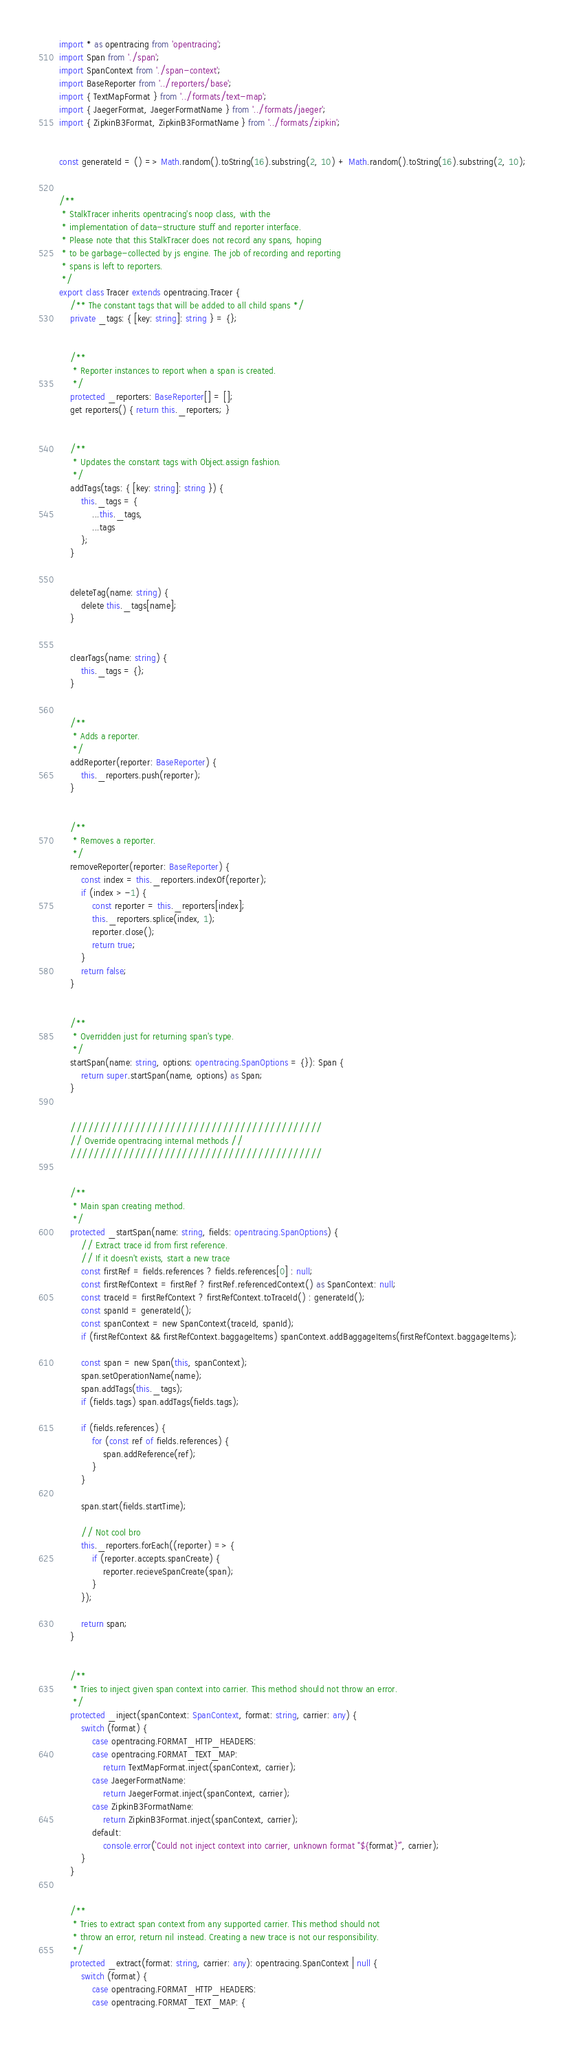Convert code to text. <code><loc_0><loc_0><loc_500><loc_500><_TypeScript_>import * as opentracing from 'opentracing';
import Span from './span';
import SpanContext from './span-context';
import BaseReporter from '../reporters/base';
import { TextMapFormat } from '../formats/text-map';
import { JaegerFormat, JaegerFormatName } from '../formats/jaeger';
import { ZipkinB3Format, ZipkinB3FormatName } from '../formats/zipkin';


const generateId = () => Math.random().toString(16).substring(2, 10) + Math.random().toString(16).substring(2, 10);


/**
 * StalkTracer inherits opentracing's noop class, with the
 * implementation of data-structure stuff and reporter interface.
 * Please note that this StalkTracer does not record any spans, hoping
 * to be garbage-collected by js engine. The job of recording and reporting
 * spans is left to reporters.
 */
export class Tracer extends opentracing.Tracer {
    /** The constant tags that will be added to all child spans */
    private _tags: { [key: string]: string } = {};


    /**
     * Reporter instances to report when a span is created.
     */
    protected _reporters: BaseReporter[] = [];
    get reporters() { return this._reporters; }


    /**
     * Updates the constant tags with Object.assign fashion.
     */
    addTags(tags: { [key: string]: string }) {
        this._tags = {
            ...this._tags,
            ...tags
        };
    }


    deleteTag(name: string) {
        delete this._tags[name];
    }


    clearTags(name: string) {
        this._tags = {};
    }


    /**
     * Adds a reporter.
     */
    addReporter(reporter: BaseReporter) {
        this._reporters.push(reporter);
    }


    /**
     * Removes a reporter.
     */
    removeReporter(reporter: BaseReporter) {
        const index = this._reporters.indexOf(reporter);
        if (index > -1) {
            const reporter = this._reporters[index];
            this._reporters.splice(index, 1);
            reporter.close();
            return true;
        }
        return false;
    }


    /**
     * Overridden just for returning span's type.
     */
    startSpan(name: string, options: opentracing.SpanOptions = {}): Span {
        return super.startSpan(name, options) as Span;
    }


    ///////////////////////////////////////////
    // Override opentracing internal methods //
    ///////////////////////////////////////////


    /**
     * Main span creating method.
     */
    protected _startSpan(name: string, fields: opentracing.SpanOptions) {
        // Extract trace id from first reference.
        // If it doesn't exists, start a new trace
        const firstRef = fields.references ? fields.references[0] : null;
        const firstRefContext = firstRef ? firstRef.referencedContext() as SpanContext: null;
        const traceId = firstRefContext ? firstRefContext.toTraceId() : generateId();
        const spanId = generateId();
        const spanContext = new SpanContext(traceId, spanId);
        if (firstRefContext && firstRefContext.baggageItems) spanContext.addBaggageItems(firstRefContext.baggageItems);

        const span = new Span(this, spanContext);
        span.setOperationName(name);
        span.addTags(this._tags);
        if (fields.tags) span.addTags(fields.tags);

        if (fields.references) {
            for (const ref of fields.references) {
                span.addReference(ref);
            }
        }

        span.start(fields.startTime);

        // Not cool bro
        this._reporters.forEach((reporter) => {
            if (reporter.accepts.spanCreate) {
                reporter.recieveSpanCreate(span);
            }
        });

        return span;
    }


    /**
     * Tries to inject given span context into carrier. This method should not throw an error.
     */
    protected _inject(spanContext: SpanContext, format: string, carrier: any) {
        switch (format) {
            case opentracing.FORMAT_HTTP_HEADERS:
            case opentracing.FORMAT_TEXT_MAP:
                return TextMapFormat.inject(spanContext, carrier);
            case JaegerFormatName:
                return JaegerFormat.inject(spanContext, carrier);
            case ZipkinB3FormatName:
                return ZipkinB3Format.inject(spanContext, carrier);
            default:
                console.error(`Could not inject context into carrier, unknown format "${format}"`, carrier);
        }
    }


    /**
     * Tries to extract span context from any supported carrier. This method should not
     * throw an error, return nil instead. Creating a new trace is not our responsibility.
     */
    protected _extract(format: string, carrier: any): opentracing.SpanContext | null {
        switch (format) {
            case opentracing.FORMAT_HTTP_HEADERS:
            case opentracing.FORMAT_TEXT_MAP: {</code> 